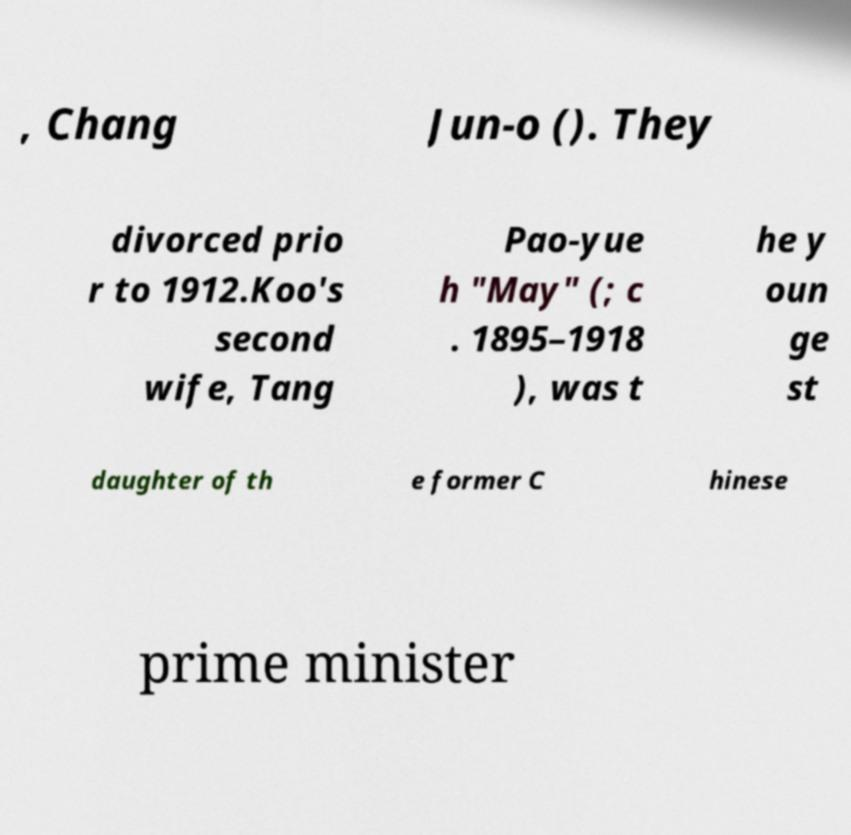Can you accurately transcribe the text from the provided image for me? , Chang Jun-o (). They divorced prio r to 1912.Koo's second wife, Tang Pao-yue h "May" (; c . 1895–1918 ), was t he y oun ge st daughter of th e former C hinese prime minister 